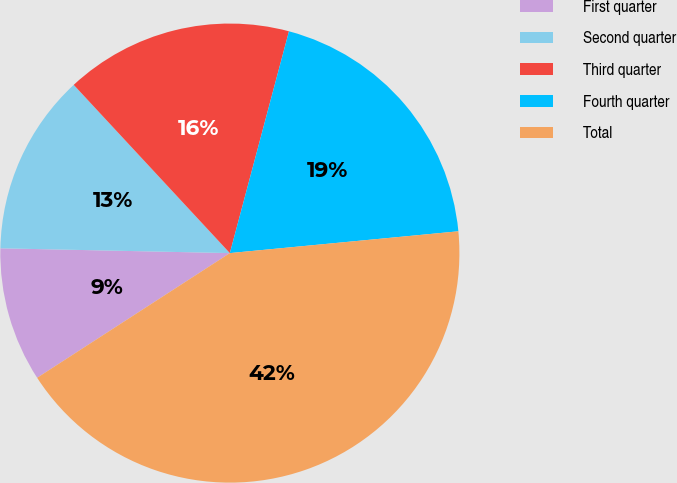Convert chart. <chart><loc_0><loc_0><loc_500><loc_500><pie_chart><fcel>First quarter<fcel>Second quarter<fcel>Third quarter<fcel>Fourth quarter<fcel>Total<nl><fcel>9.47%<fcel>12.76%<fcel>16.05%<fcel>19.34%<fcel>42.37%<nl></chart> 